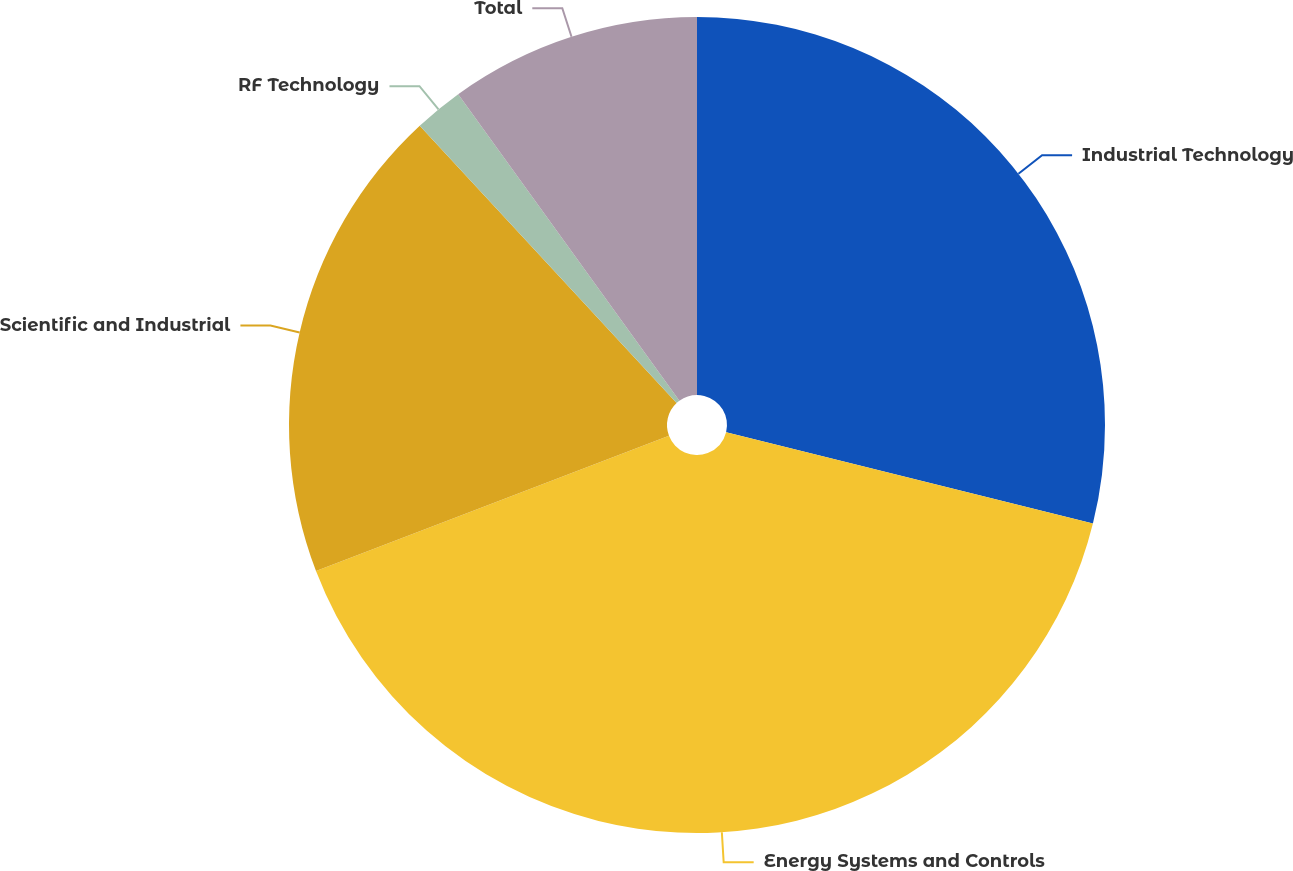Convert chart. <chart><loc_0><loc_0><loc_500><loc_500><pie_chart><fcel>Industrial Technology<fcel>Energy Systems and Controls<fcel>Scientific and Industrial<fcel>RF Technology<fcel>Total<nl><fcel>28.88%<fcel>40.29%<fcel>18.93%<fcel>1.94%<fcel>9.95%<nl></chart> 